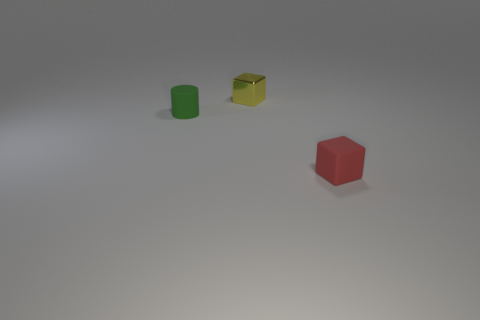What is the spatial arrangement of the objects in relation to one another? The green cylinder, yellow cube, and red cube are dispersed with some distance between them, positioned roughly in a diagonal line from the perspective of the viewer. This arrangement forms a visual pathway that leads the eye from one object to the next. 